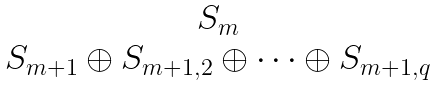Convert formula to latex. <formula><loc_0><loc_0><loc_500><loc_500>\begin{matrix} S _ { m } \\ S _ { m + 1 } \oplus S _ { m + 1 , 2 } \oplus \cdots \oplus S _ { m + 1 , q } \end{matrix}</formula> 